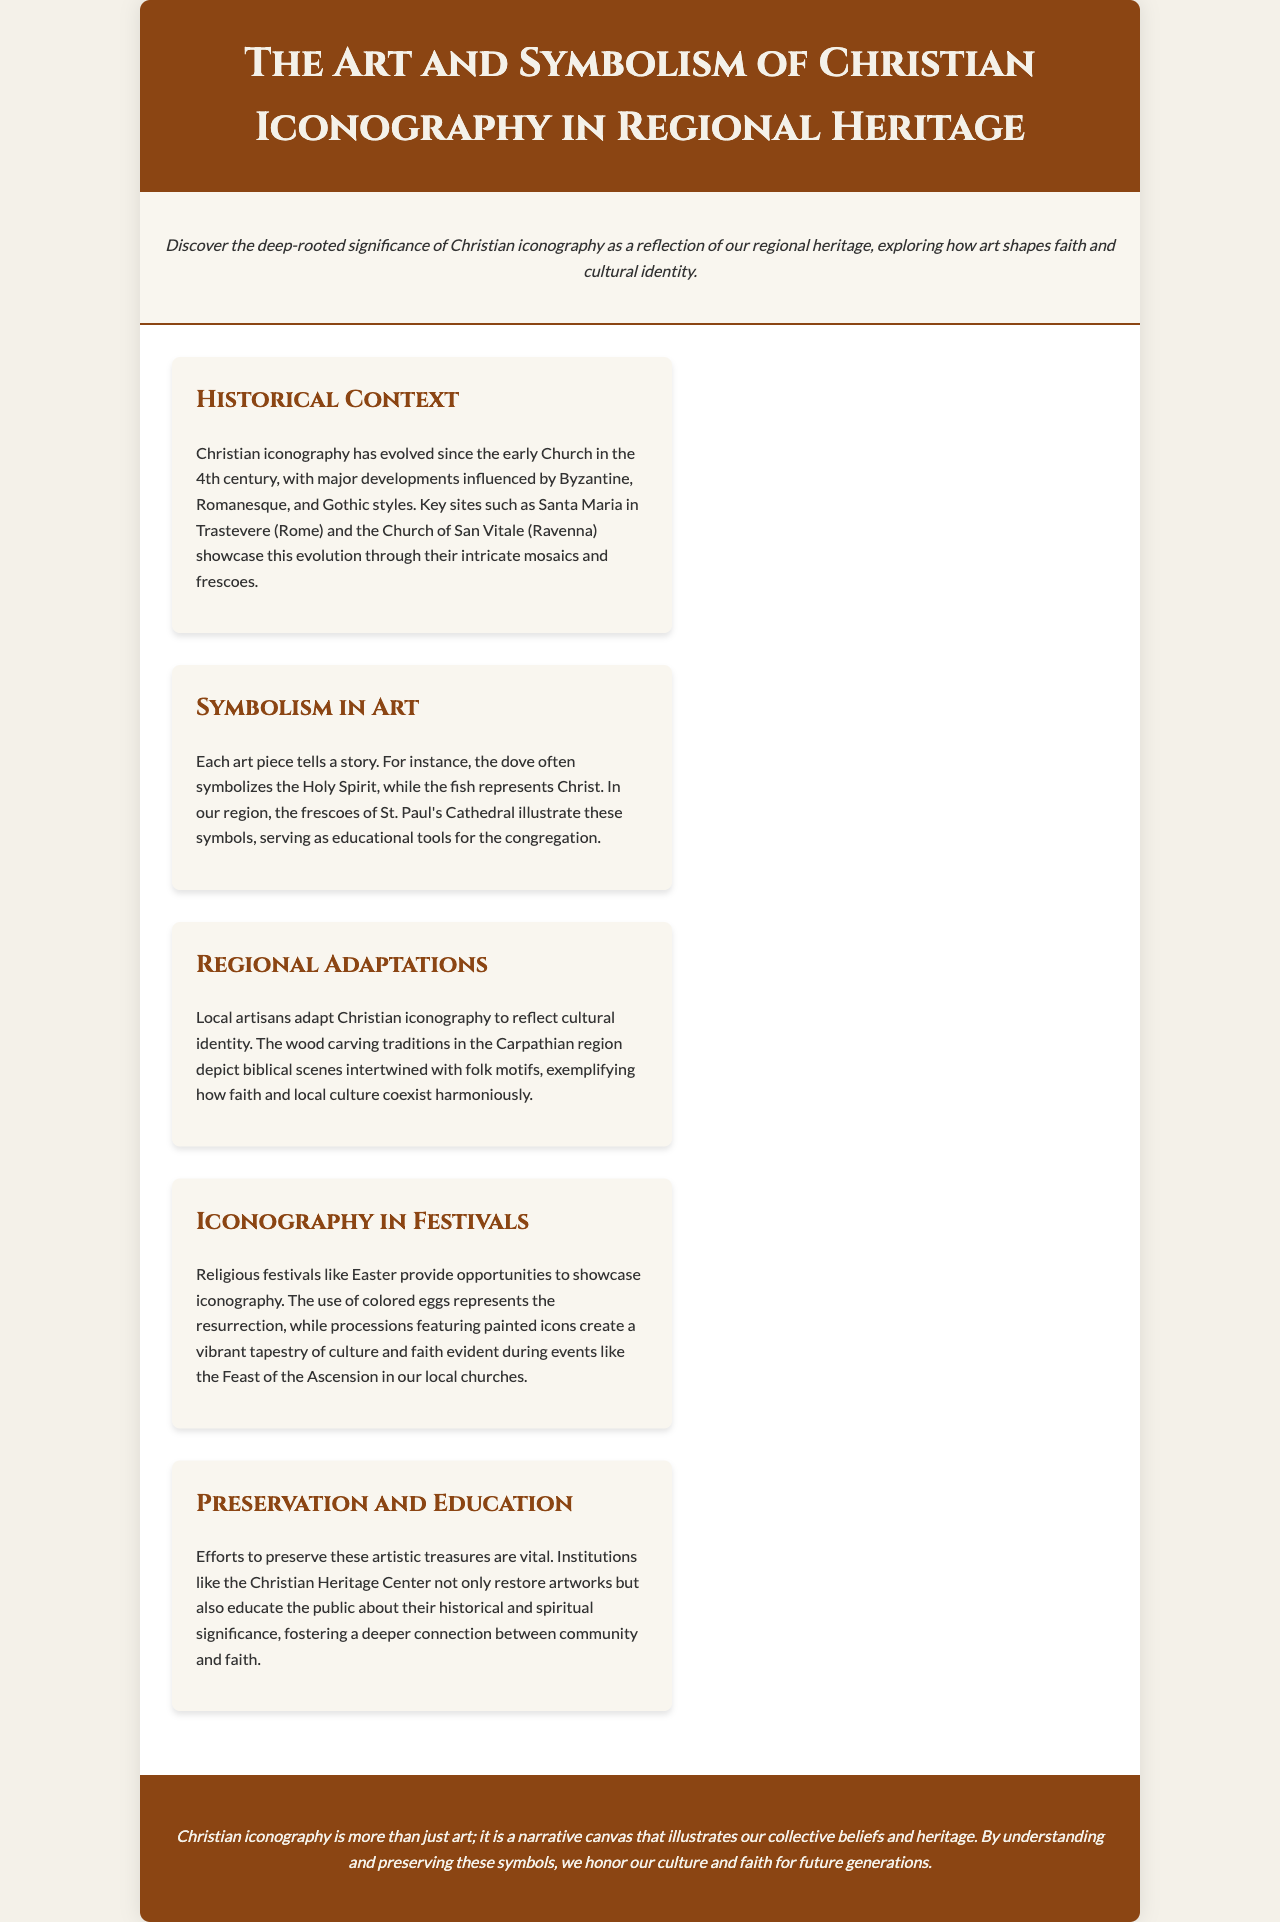What is the primary focus of the brochure? The brochure focuses on the significance of Christian iconography in reflecting regional heritage and cultural identity.
Answer: Significance of Christian iconography When did Christian iconography begin to evolve? The document states that Christian iconography began to evolve in the 4th century.
Answer: 4th century Which two key sites are highlighted for their iconographic development? The highlighted sites are Santa Maria in Trastevere and the Church of San Vitale.
Answer: Santa Maria in Trastevere, Church of San Vitale What does the dove often symbolize in Christian art? According to the brochure, the dove symbolizes the Holy Spirit.
Answer: Holy Spirit How are local artisans depicted in the context of iconography? The brochure mentions that local artisans adapt iconography to reflect cultural identity, particularly in the Carpathian region.
Answer: Reflect cultural identity What important role do colored eggs have in festivals? The colored eggs symbolize the resurrection during Easter.
Answer: Resurrection What institution works on the preservation of Christian artworks? The document mentions the Christian Heritage Center as an institution involved in restoration and education.
Answer: Christian Heritage Center Which festival is mentioned in relation to iconography? The Feast of the Ascension is mentioned as a festival that showcases iconography.
Answer: Feast of the Ascension What is emphasized about the narrative quality of Christian iconography? The brochure emphasizes that Christian iconography illustrates collective beliefs and heritage.
Answer: Collective beliefs and heritage 